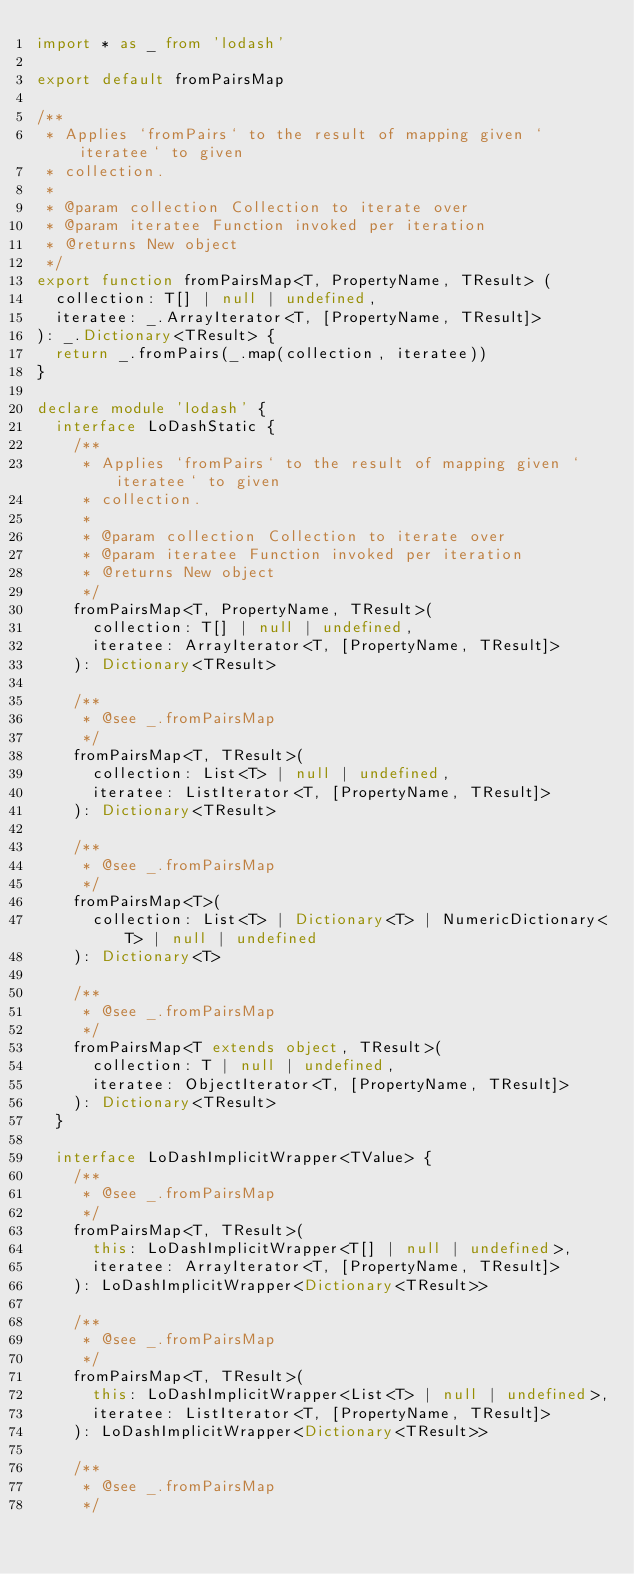Convert code to text. <code><loc_0><loc_0><loc_500><loc_500><_TypeScript_>import * as _ from 'lodash'

export default fromPairsMap

/**
 * Applies `fromPairs` to the result of mapping given `iteratee` to given
 * collection.
 *
 * @param collection Collection to iterate over
 * @param iteratee Function invoked per iteration
 * @returns New object
 */
export function fromPairsMap<T, PropertyName, TResult> (
  collection: T[] | null | undefined,
  iteratee: _.ArrayIterator<T, [PropertyName, TResult]>
): _.Dictionary<TResult> {
  return _.fromPairs(_.map(collection, iteratee))
}

declare module 'lodash' {
  interface LoDashStatic {
    /**
     * Applies `fromPairs` to the result of mapping given `iteratee` to given
     * collection.
     *
     * @param collection Collection to iterate over
     * @param iteratee Function invoked per iteration
     * @returns New object
     */
    fromPairsMap<T, PropertyName, TResult>(
      collection: T[] | null | undefined,
      iteratee: ArrayIterator<T, [PropertyName, TResult]>
    ): Dictionary<TResult>

    /**
     * @see _.fromPairsMap
     */
    fromPairsMap<T, TResult>(
      collection: List<T> | null | undefined,
      iteratee: ListIterator<T, [PropertyName, TResult]>
    ): Dictionary<TResult>

    /**
     * @see _.fromPairsMap
     */
    fromPairsMap<T>(
      collection: List<T> | Dictionary<T> | NumericDictionary<T> | null | undefined
    ): Dictionary<T>

    /**
     * @see _.fromPairsMap
     */
    fromPairsMap<T extends object, TResult>(
      collection: T | null | undefined,
      iteratee: ObjectIterator<T, [PropertyName, TResult]>
    ): Dictionary<TResult>
  }

  interface LoDashImplicitWrapper<TValue> {
    /**
     * @see _.fromPairsMap
     */
    fromPairsMap<T, TResult>(
      this: LoDashImplicitWrapper<T[] | null | undefined>,
      iteratee: ArrayIterator<T, [PropertyName, TResult]>
    ): LoDashImplicitWrapper<Dictionary<TResult>>

    /**
     * @see _.fromPairsMap
     */
    fromPairsMap<T, TResult>(
      this: LoDashImplicitWrapper<List<T> | null | undefined>,
      iteratee: ListIterator<T, [PropertyName, TResult]>
    ): LoDashImplicitWrapper<Dictionary<TResult>>

    /**
     * @see _.fromPairsMap
     */</code> 